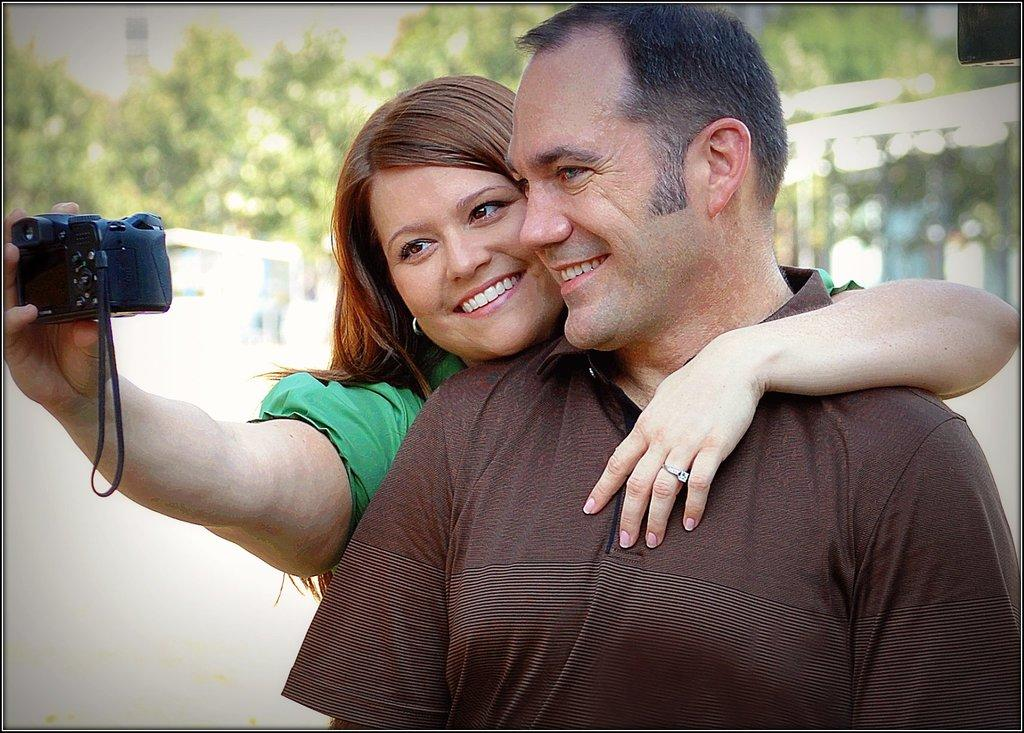How many people are in the image? There are two persons in the image. What is the person at the front wearing? The person at the front is wearing a brown t-shirt. What is the person at the back holding? The person at the back is holding a camera in her hand. What can be seen in the background of the image? There are trees visible in the background of the image. What type of shoes are the persons wearing in the image? The provided facts do not mention any shoes being worn by the persons in the image. 